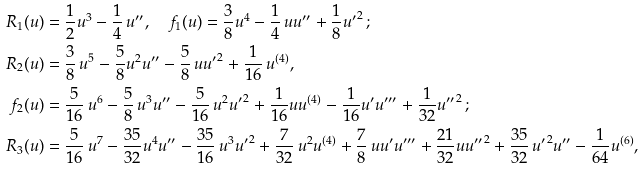Convert formula to latex. <formula><loc_0><loc_0><loc_500><loc_500>R _ { 1 } ( u ) & = \frac { 1 } { 2 } u ^ { 3 } - \frac { 1 } { 4 } \, u ^ { \prime \prime } , \quad f _ { 1 } ( u ) = \frac { 3 } { 8 } u ^ { 4 } - \frac { 1 } { 4 } \, u u ^ { \prime \prime } + \frac { 1 } { 8 } { u ^ { \prime } } ^ { 2 } \, ; \\ R _ { 2 } ( u ) & = \frac { 3 } { 8 } \, u ^ { 5 } - \frac { 5 } { 8 } u ^ { 2 } u ^ { \prime \prime } - \frac { 5 } { 8 } \, u { u ^ { \prime } } ^ { 2 } + \frac { 1 } { 1 6 } \, u ^ { ( 4 ) } , \\ f _ { 2 } ( u ) & = \frac { 5 } { 1 6 } \, u ^ { 6 } - \frac { 5 } { 8 } \, u ^ { 3 } u ^ { \prime \prime } - \frac { 5 } { 1 6 } \, u ^ { 2 } { u ^ { \prime } } ^ { 2 } + \frac { 1 } { 1 6 } u u ^ { ( 4 ) } - \frac { 1 } { 1 6 } u ^ { \prime } u ^ { \prime \prime \prime } + \frac { 1 } { 3 2 } { u ^ { \prime \prime } } ^ { 2 } \, ; \\ R _ { 3 } ( u ) & = \frac { 5 } { 1 6 } \, u ^ { 7 } - \frac { 3 5 } { 3 2 } u ^ { 4 } u ^ { \prime \prime } - \frac { 3 5 } { 1 6 } \, u ^ { 3 } { u ^ { \prime } } ^ { 2 } + \frac { 7 } { 3 2 } \, u ^ { 2 } u ^ { ( 4 ) } + \frac { 7 } { 8 } \, u u ^ { \prime } u ^ { \prime \prime \prime } + \frac { 2 1 } { 3 2 } u { u ^ { \prime \prime } } ^ { 2 } + \frac { 3 5 } { 3 2 } \, { u ^ { \prime } } ^ { 2 } u ^ { \prime \prime } - \frac { 1 } { 6 4 } u ^ { ( 6 ) } ,</formula> 